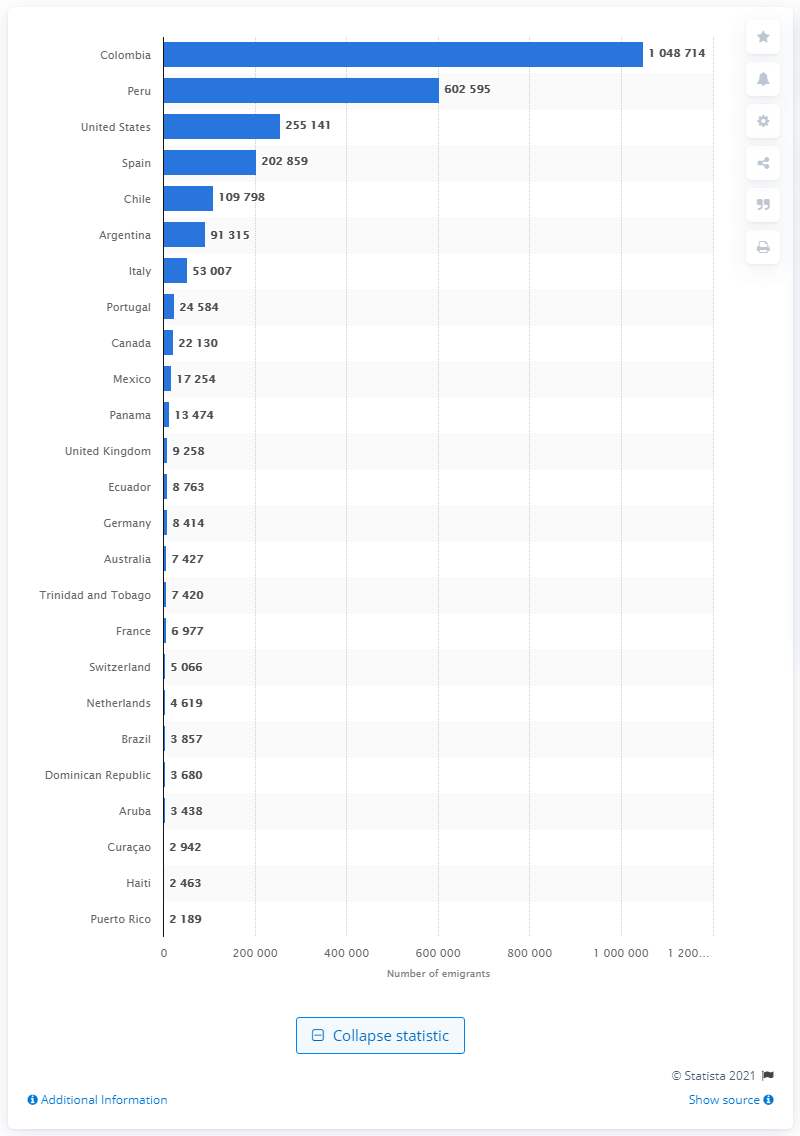List a handful of essential elements in this visual. Venezuelan emigrants primarily sought to relocate to Colombia. 